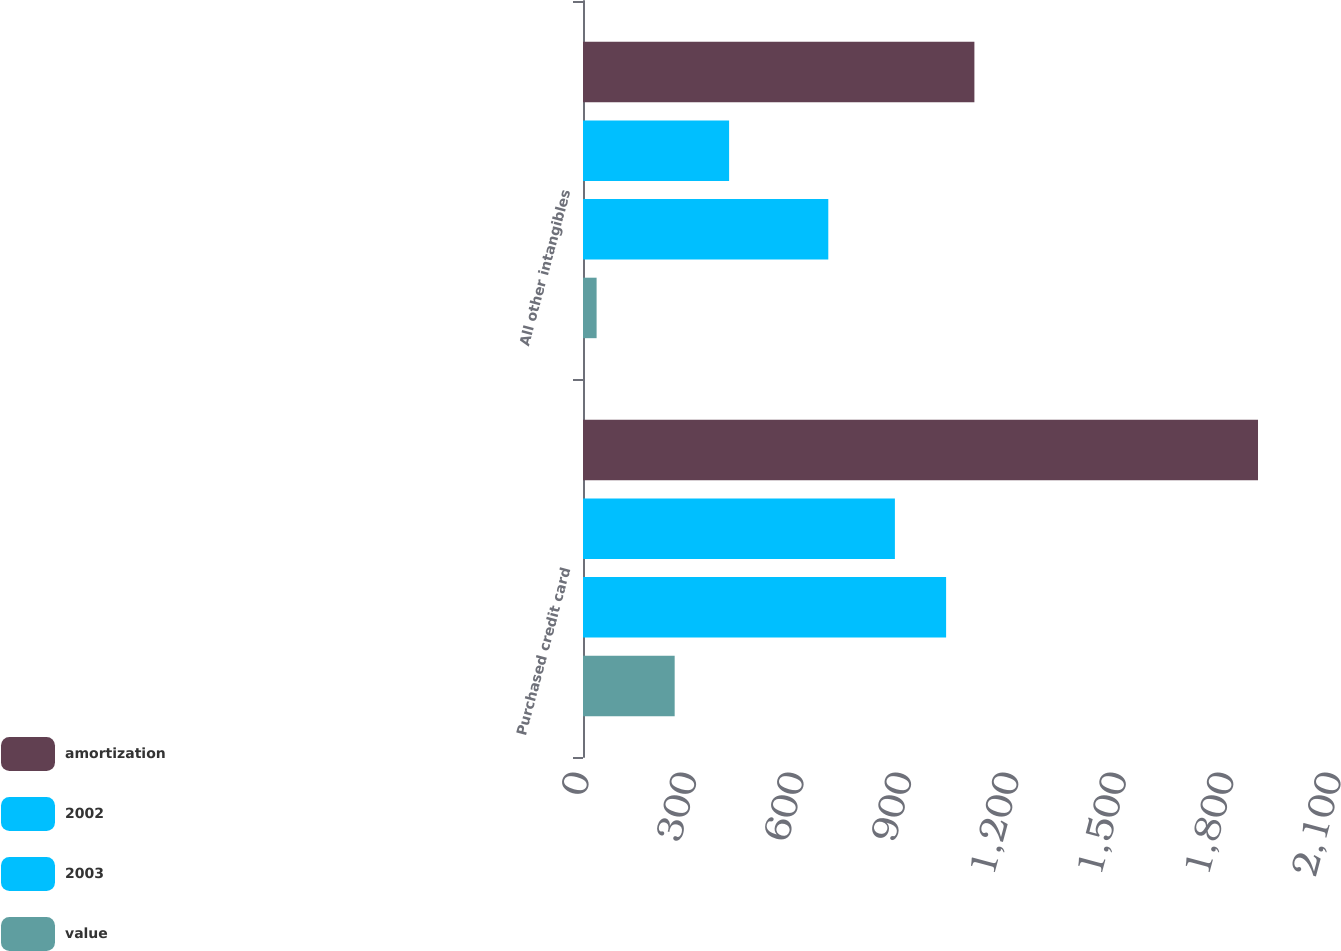Convert chart to OTSL. <chart><loc_0><loc_0><loc_500><loc_500><stacked_bar_chart><ecel><fcel>Purchased credit card<fcel>All other intangibles<nl><fcel>amortization<fcel>1885<fcel>1093<nl><fcel>2002<fcel>871<fcel>408<nl><fcel>2003<fcel>1014<fcel>685<nl><fcel>value<fcel>256<fcel>38<nl></chart> 